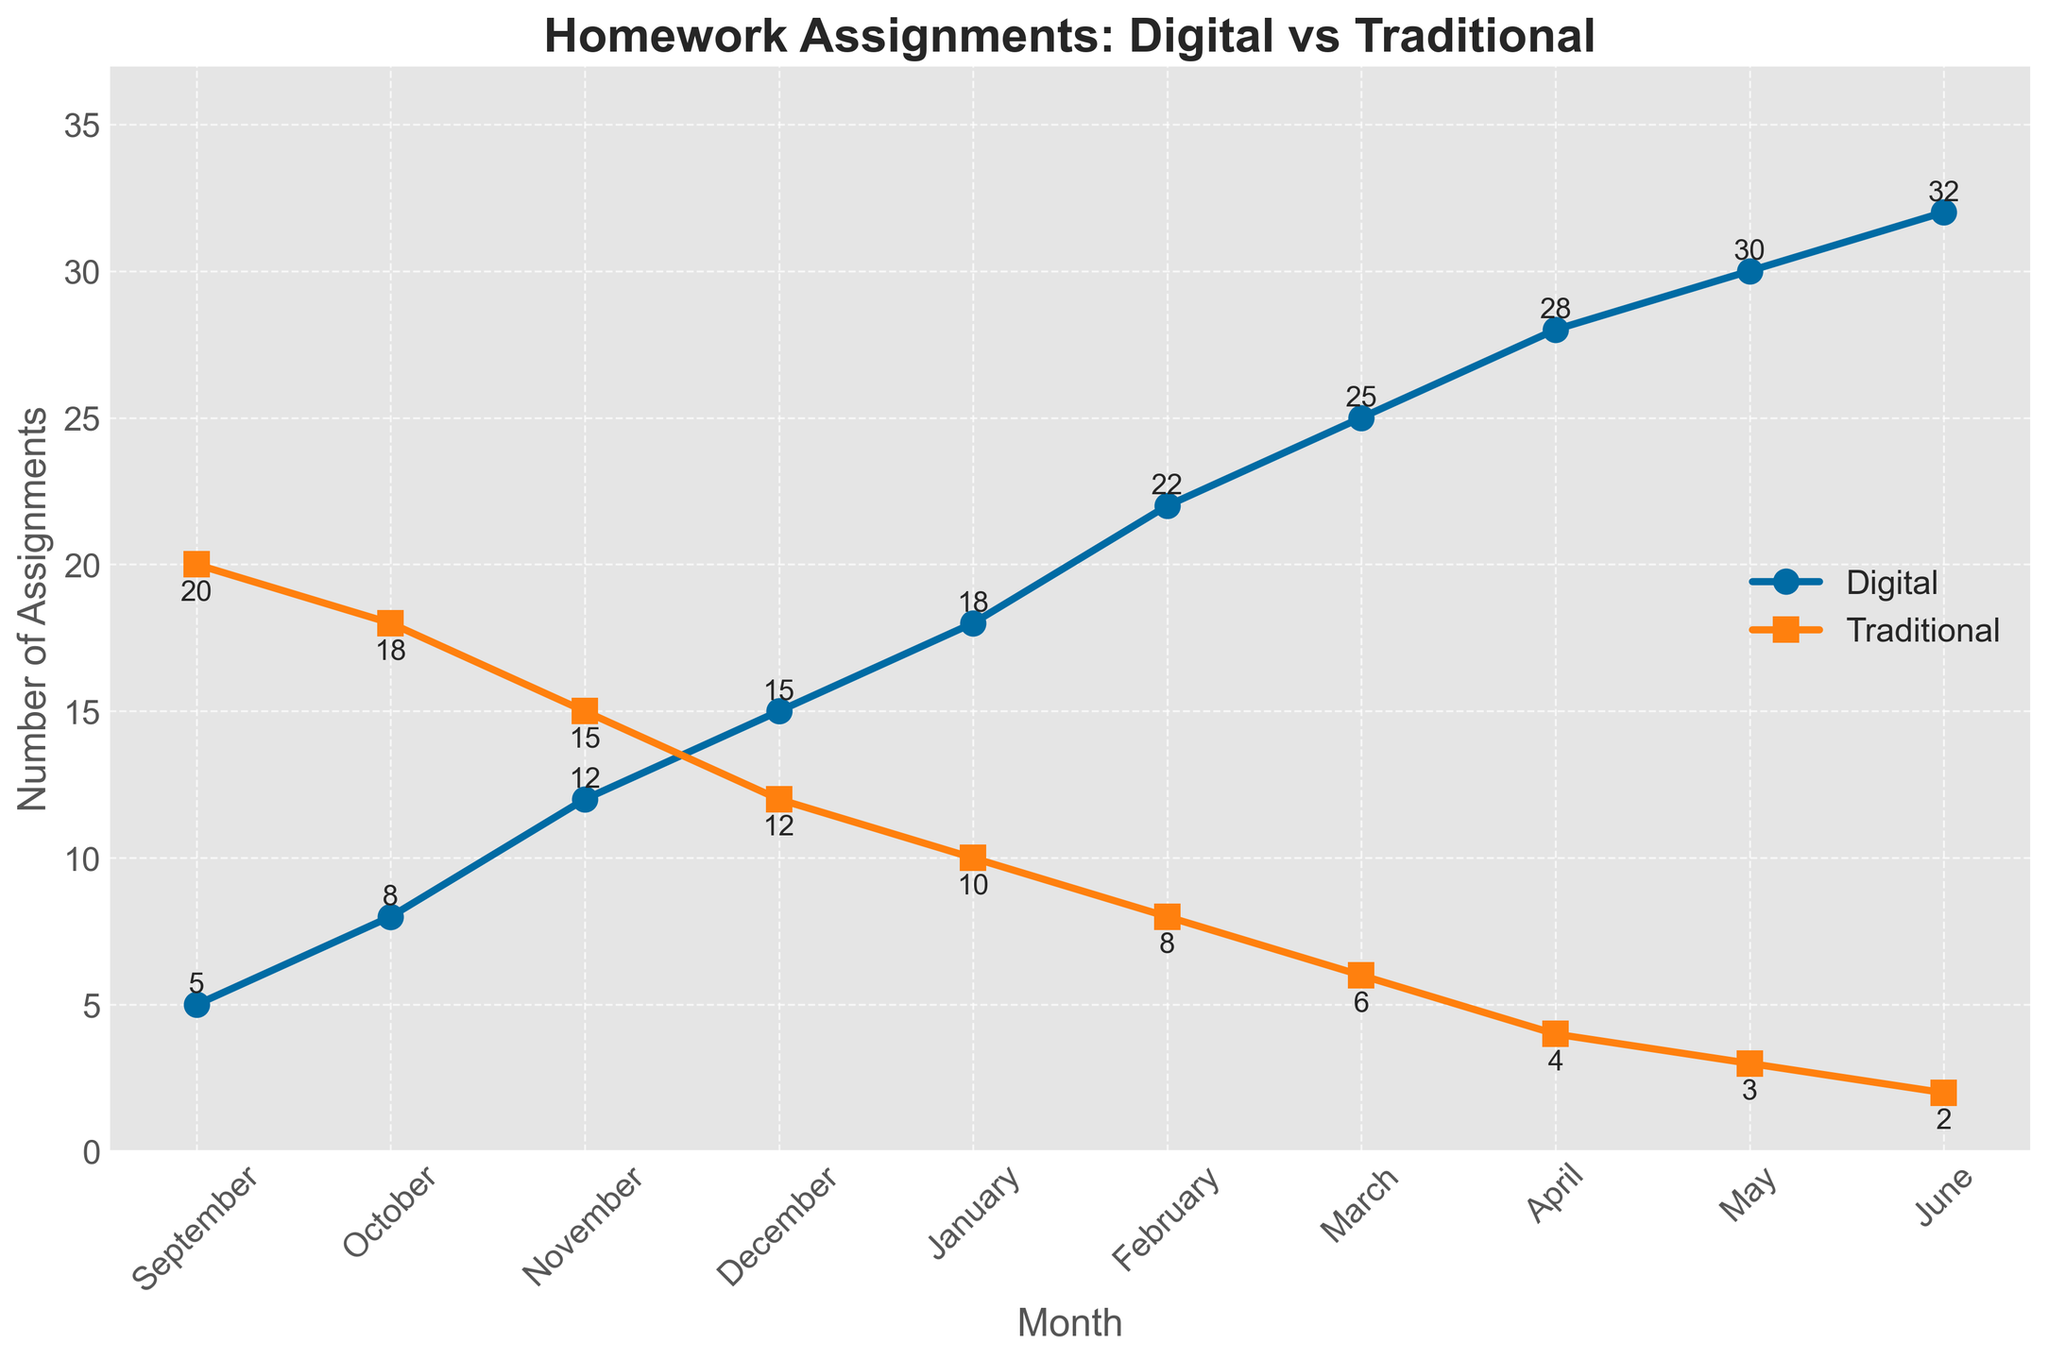How does the number of digital assignments completed in January compare to the number in May? In January, 18 digital assignments were completed, while in May, 30 digital assignments were completed. To compare, 30 is greater than 18.
Answer: The number in May is greater than in January What is the total number of traditional assignments completed from November to February? The number of traditional assignments completed from November to February are 15 (November), 12 (December), 10 (January), and 8 (February). Adding these up: 15 + 12 + 10 + 8 = 45.
Answer: 45 What month has the highest number of digital assignments? By observing the line for digital assignments, the highest number of digital assignments is at its peak in June, with 32 assignments.
Answer: June What is the difference in the number of traditional assignments completed between September and June? In September, 20 traditional assignments were completed, and in June, 2 traditional assignments were completed. The difference is 20 - 2 = 18.
Answer: 18 Which month shows an equal number of digital and traditional assignments completed? By observing the lines for digital and traditional assignments, no month shows an equal number of digital and traditional assignments completed.
Answer: None Which type of assignment shows more consistent completion patterns over the months? By observing the trends, the number of traditional assignments steadily decreases each month, showing a consistent pattern. The number of digital assignments consistently increases each month, but with different increments.
Answer: Traditional In which month do digital assignments overtake traditional assignments in number? By observing the intersecting points of the lines, digital assignments overtake traditional assignments in December (12 digital vs 12 traditional).
Answer: December What is the average number of digital assignments completed in the first half of the year (September to February)? The numbers are 5 (September), 8 (October), 12 (November), 15 (December), 18 (January), and 22 (February). Adding these up: 5 + 8 + 12 + 15 + 18 + 22 = 80. Dividing by 6 months: 80 / 6 ≈ 13.33.
Answer: 13.33 What is the overall trend of digital assignments throughout the school year? By following the line for digital assignments from September to June, we see a continuous upward trend, indicating an increase in the number of digital assignments.
Answer: Continuous upward trend 